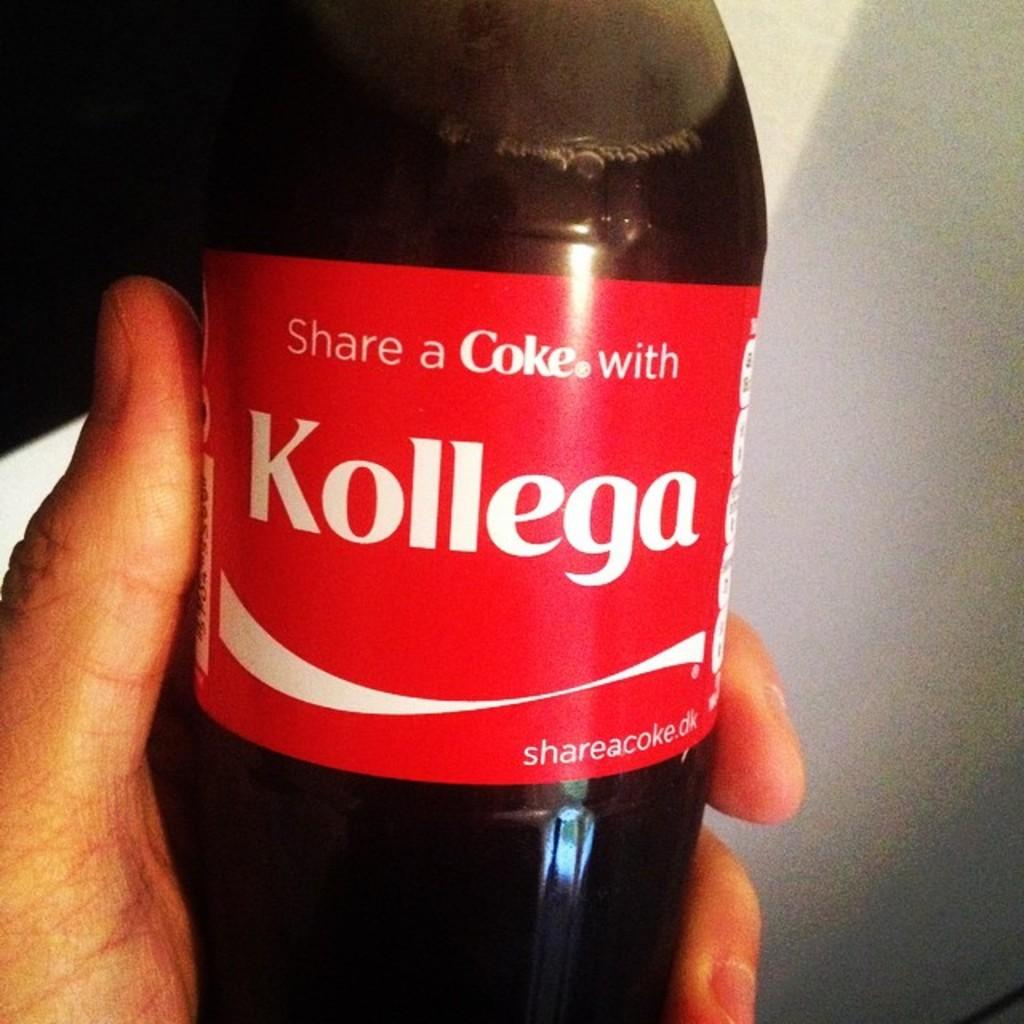Who or what is present in the image? There is a person in the image. What is the person holding in their hand? The person is holding a coke bottle in their hand. How many frogs can be seen crying in the image? There are no frogs or crying in the image; it features a person holding a coke bottle. 